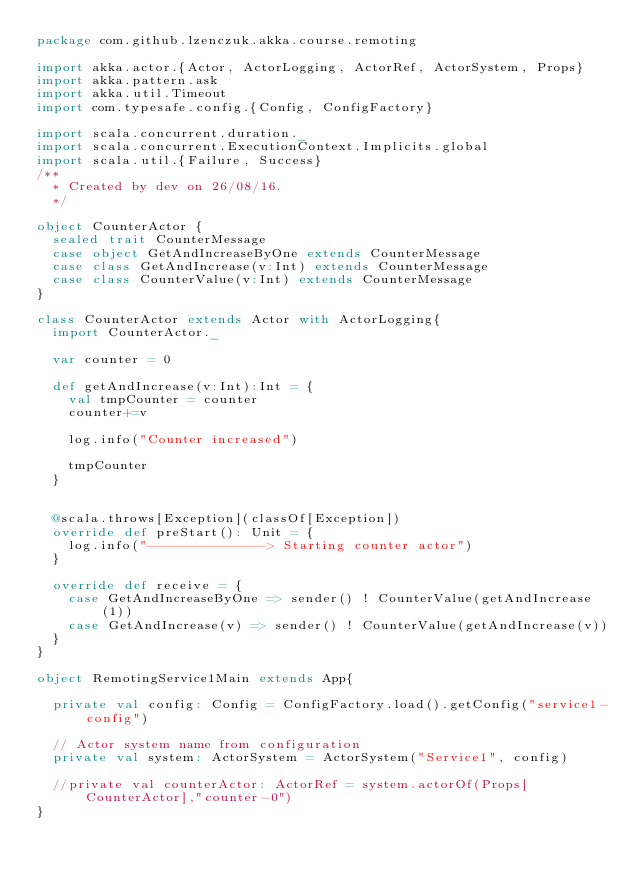<code> <loc_0><loc_0><loc_500><loc_500><_Scala_>package com.github.lzenczuk.akka.course.remoting

import akka.actor.{Actor, ActorLogging, ActorRef, ActorSystem, Props}
import akka.pattern.ask
import akka.util.Timeout
import com.typesafe.config.{Config, ConfigFactory}

import scala.concurrent.duration._
import scala.concurrent.ExecutionContext.Implicits.global
import scala.util.{Failure, Success}
/**
  * Created by dev on 26/08/16.
  */

object CounterActor {
  sealed trait CounterMessage
  case object GetAndIncreaseByOne extends CounterMessage
  case class GetAndIncrease(v:Int) extends CounterMessage
  case class CounterValue(v:Int) extends CounterMessage
}

class CounterActor extends Actor with ActorLogging{
  import CounterActor._

  var counter = 0

  def getAndIncrease(v:Int):Int = {
    val tmpCounter = counter
    counter+=v

    log.info("Counter increased")

    tmpCounter
  }


  @scala.throws[Exception](classOf[Exception])
  override def preStart(): Unit = {
    log.info("---------------> Starting counter actor")
  }

  override def receive = {
    case GetAndIncreaseByOne => sender() ! CounterValue(getAndIncrease(1))
    case GetAndIncrease(v) => sender() ! CounterValue(getAndIncrease(v))
  }
}

object RemotingService1Main extends App{

  private val config: Config = ConfigFactory.load().getConfig("service1-config")

  // Actor system name from configuration
  private val system: ActorSystem = ActorSystem("Service1", config)

  //private val counterActor: ActorRef = system.actorOf(Props[CounterActor],"counter-0")
}
</code> 